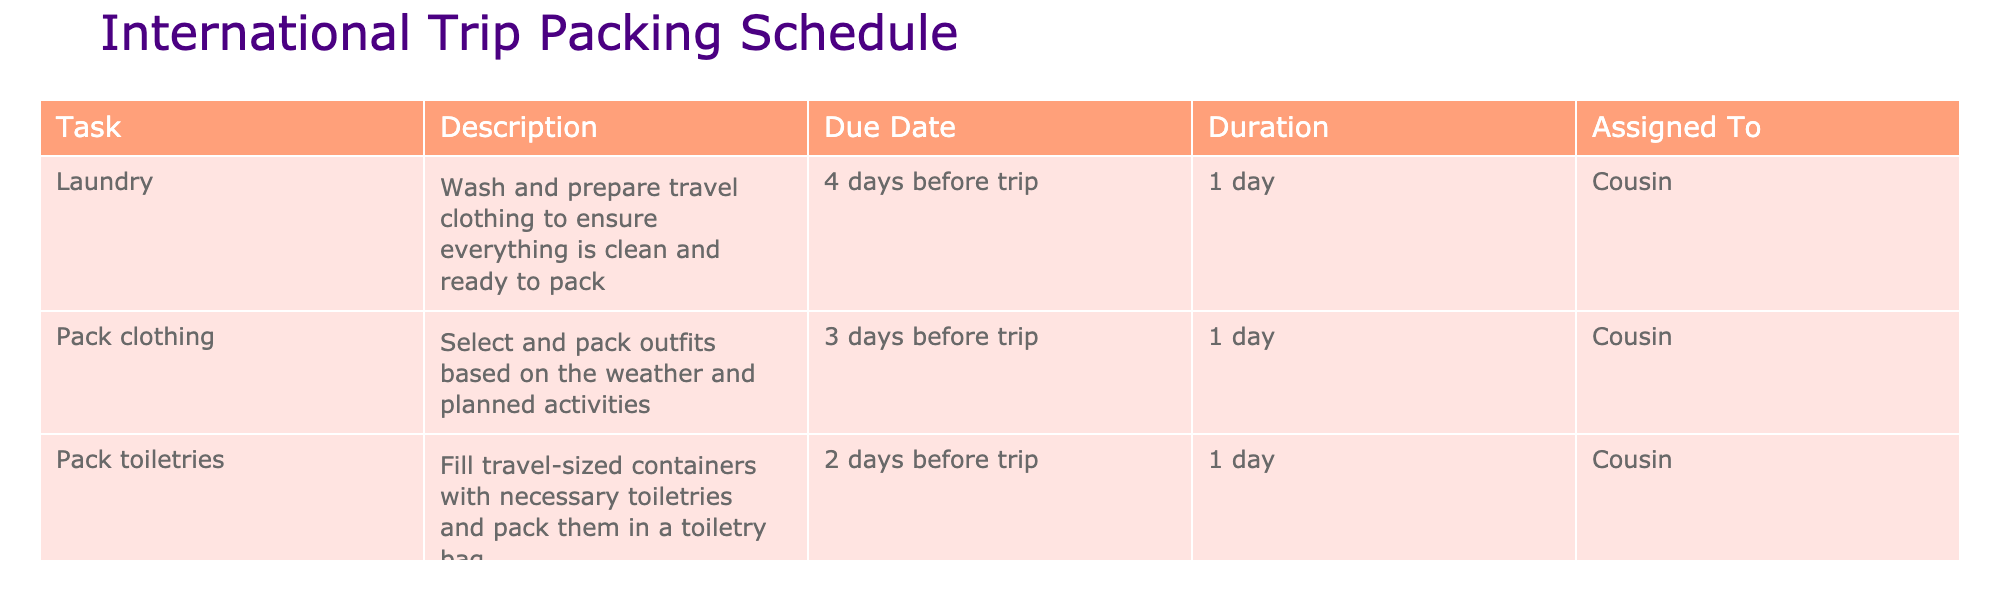What is the due date for packing toiletries? The table shows that the due date for packing toiletries is listed as "2 days before trip."
Answer: 2 days before trip How long is the laundry task scheduled to take? The duration for the laundry task in the table is "1 day."
Answer: 1 day What is the last task to be completed before the trip? According to the table, the last task listed is "Final check of luggage," which is scheduled for "1 day before trip."
Answer: Final check of luggage If packing clothing takes 1 day and is done 3 days before the trip, when will that be completed? The packing clothing task is scheduled for "3 days before trip," and since it takes 1 day, it will be completed by then. Thus, it will be completed on that same day.
Answer: 3 days before trip Is it true that the laundry task is done 4 days before the trip? Yes, the table states that the laundry task is indeed scheduled for "4 days before trip."
Answer: Yes What is the total duration of all tasks listed in the table? The total duration consists of 1 day for laundry, 1 day for packing clothing, 1 day for packing toiletries, and 2 hours for the final check of luggage. Converting 2 hours into days gives us approximately 0.08 days. Adding these up: 1 + 1 + 1 + 0.08 = 3.08 days.
Answer: 3.08 days Which task requires the longest duration? By comparing the durations listed, the "Final check of luggage" takes 2 hours, while the laundry, packing clothing, and packing toiletries each take 1 day (which equals 24 hours). Therefore, laundry, packing clothing, and packing toiletries each take a longer duration than the final check of luggage.
Answer: Laundry, Pack clothing, and Pack toiletries How many tasks need to be completed before the trip starts? The table lists four tasks: laundry, pack clothing, pack toiletries, and final check of luggage. All are scheduled to be completed before the trip starts, making a total of four tasks.
Answer: 4 tasks How many days before the trip does the first task need to be completed? The first task (laundry) is scheduled for completion 4 days before the trip.
Answer: 4 days before the trip 